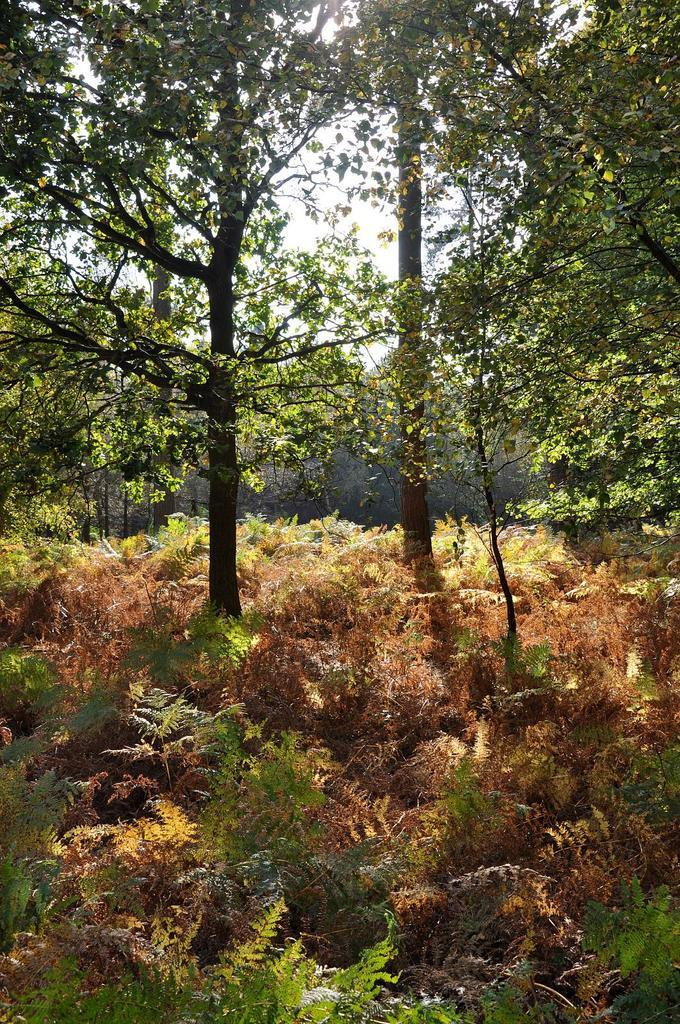What type of vegetation can be seen in the image? There are small plants and trees in the image. What can be seen in the background of the image? The sky is visible in the background of the image. What type of line is being used to cook the meal in the image? There is no line or meal present in the image; it features small plants, trees, and the sky. How many fowls can be seen in the image? There are no fowls present in the image. 